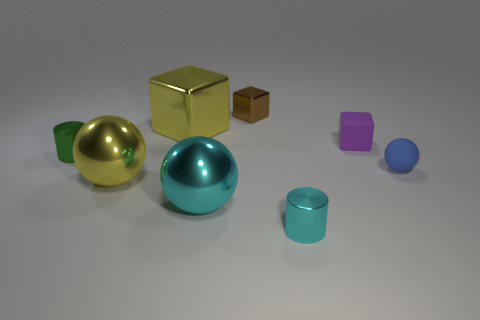Add 1 small purple matte cubes. How many objects exist? 9 Subtract all balls. How many objects are left? 5 Subtract all big shiny cylinders. Subtract all small green objects. How many objects are left? 7 Add 4 yellow metal things. How many yellow metal things are left? 6 Add 4 large brown objects. How many large brown objects exist? 4 Subtract 1 brown blocks. How many objects are left? 7 